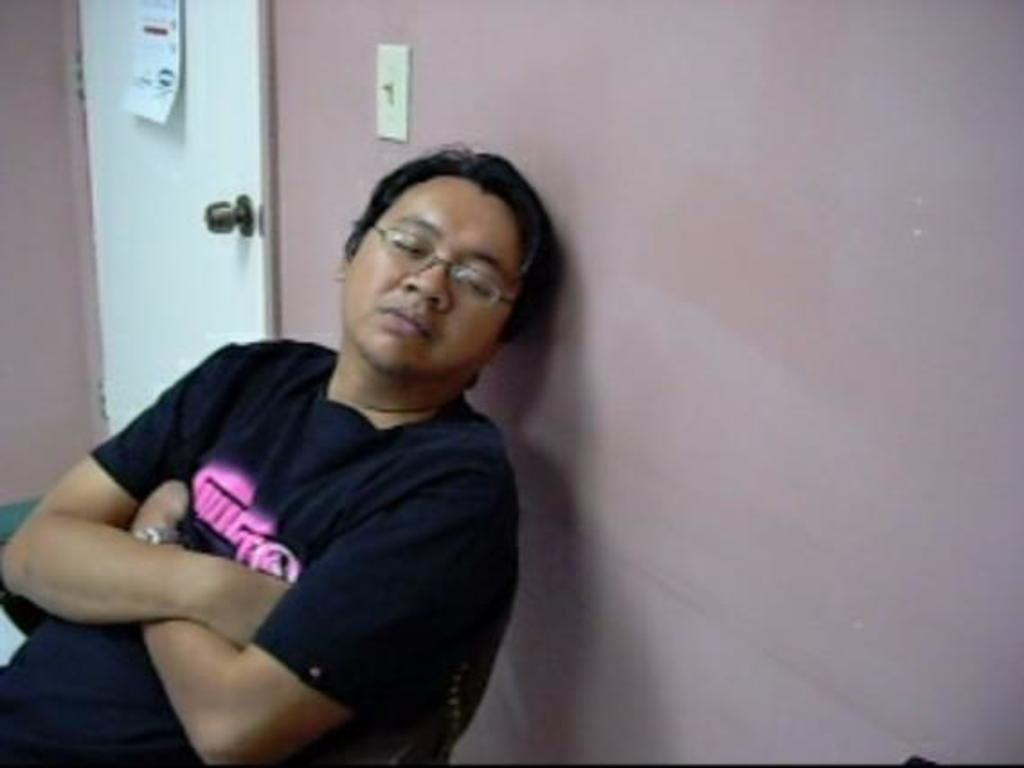Who is present in the image? There is a man in the image. What is the man doing in the image? The man is sitting on a chair and resting his head against a wall. What can be seen in the background of the image? There is a door in the image. How many trucks can be seen in the alley behind the man in the image? There are no trucks or alley present in the image; it only features a man sitting on a chair and resting his head against a wall, with a door visible in the background. 